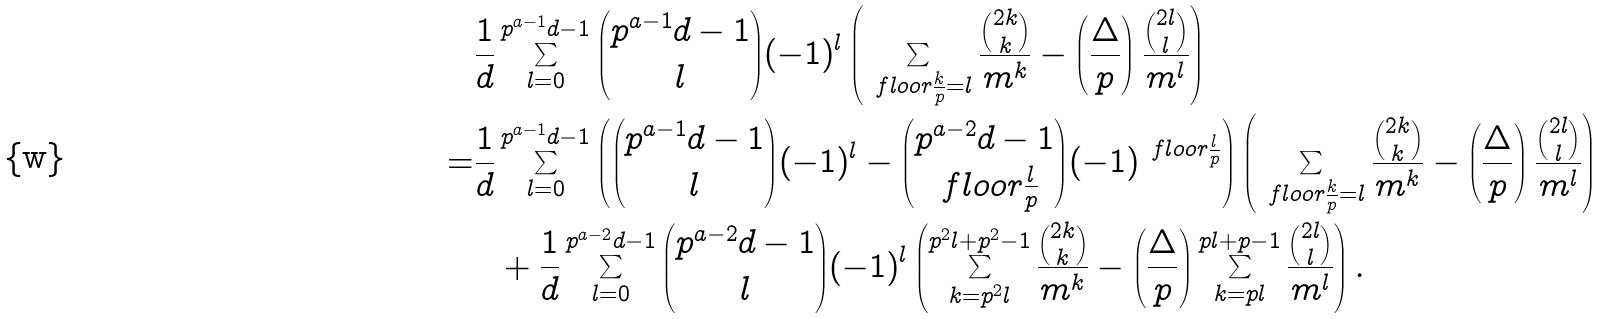Convert formula to latex. <formula><loc_0><loc_0><loc_500><loc_500>& \frac { 1 } { d } \sum _ { l = 0 } ^ { p ^ { a - 1 } d - 1 } \binom { p ^ { a - 1 } d - 1 } { l } ( - 1 ) ^ { l } \left ( \sum _ { \ f l o o r { \frac { k } { p } } = l } \frac { \binom { 2 k } { k } } { m ^ { k } } - \left ( \frac { \Delta } { p } \right ) \frac { \binom { 2 l } { l } } { m ^ { l } } \right ) \\ = & \frac { 1 } { d } \sum _ { l = 0 } ^ { p ^ { a - 1 } d - 1 } \left ( \binom { p ^ { a - 1 } d - 1 } { l } ( - 1 ) ^ { l } - \binom { p ^ { a - 2 } d - 1 } { \ f l o o r { \frac { l } { p } } } ( - 1 ) ^ { \ f l o o r { \frac { l } { p } } } \right ) \left ( \sum _ { \ f l o o r { \frac { k } { p } } = l } \frac { \binom { 2 k } { k } } { m ^ { k } } - \left ( \frac { \Delta } { p } \right ) \frac { \binom { 2 l } { l } } { m ^ { l } } \right ) \\ & \ \ + \frac { 1 } { d } \sum _ { l = 0 } ^ { p ^ { a - 2 } d - 1 } \binom { p ^ { a - 2 } d - 1 } { l } ( - 1 ) ^ { l } \left ( \sum _ { k = p ^ { 2 } l } ^ { p ^ { 2 } l + p ^ { 2 } - 1 } \frac { \binom { 2 k } { k } } { m ^ { k } } - \left ( \frac { \Delta } { p } \right ) \sum _ { k = p l } ^ { p l + p - 1 } \frac { \binom { 2 l } { l } } { m ^ { l } } \right ) .</formula> 